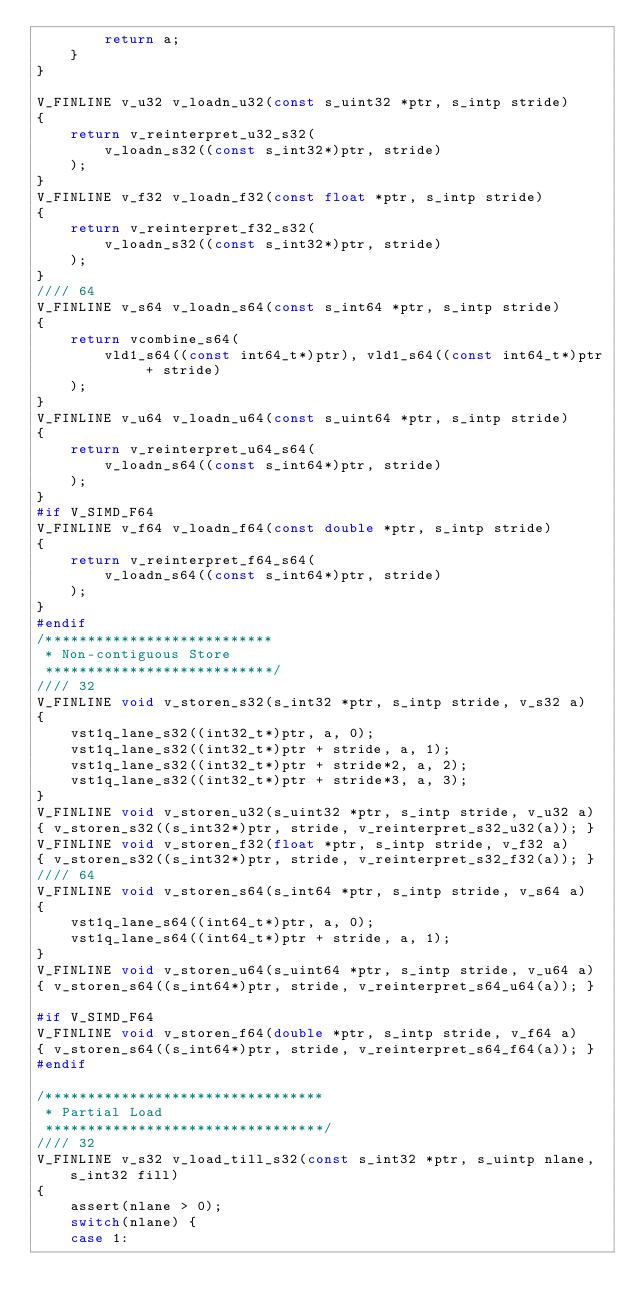Convert code to text. <code><loc_0><loc_0><loc_500><loc_500><_C_>        return a;
    }
}

V_FINLINE v_u32 v_loadn_u32(const s_uint32 *ptr, s_intp stride)
{
    return v_reinterpret_u32_s32(
        v_loadn_s32((const s_int32*)ptr, stride)
    );
}
V_FINLINE v_f32 v_loadn_f32(const float *ptr, s_intp stride)
{
    return v_reinterpret_f32_s32(
        v_loadn_s32((const s_int32*)ptr, stride)
    );
}
//// 64
V_FINLINE v_s64 v_loadn_s64(const s_int64 *ptr, s_intp stride)
{
    return vcombine_s64(
        vld1_s64((const int64_t*)ptr), vld1_s64((const int64_t*)ptr + stride)
    );
}
V_FINLINE v_u64 v_loadn_u64(const s_uint64 *ptr, s_intp stride)
{
    return v_reinterpret_u64_s64(
        v_loadn_s64((const s_int64*)ptr, stride)
    );
}
#if V_SIMD_F64
V_FINLINE v_f64 v_loadn_f64(const double *ptr, s_intp stride)
{
    return v_reinterpret_f64_s64(
        v_loadn_s64((const s_int64*)ptr, stride)
    );
}
#endif
/***************************
 * Non-contiguous Store
 ***************************/
//// 32
V_FINLINE void v_storen_s32(s_int32 *ptr, s_intp stride, v_s32 a)
{
    vst1q_lane_s32((int32_t*)ptr, a, 0);
    vst1q_lane_s32((int32_t*)ptr + stride, a, 1);
    vst1q_lane_s32((int32_t*)ptr + stride*2, a, 2);
    vst1q_lane_s32((int32_t*)ptr + stride*3, a, 3);
}
V_FINLINE void v_storen_u32(s_uint32 *ptr, s_intp stride, v_u32 a)
{ v_storen_s32((s_int32*)ptr, stride, v_reinterpret_s32_u32(a)); }
V_FINLINE void v_storen_f32(float *ptr, s_intp stride, v_f32 a)
{ v_storen_s32((s_int32*)ptr, stride, v_reinterpret_s32_f32(a)); }
//// 64
V_FINLINE void v_storen_s64(s_int64 *ptr, s_intp stride, v_s64 a)
{
    vst1q_lane_s64((int64_t*)ptr, a, 0);
    vst1q_lane_s64((int64_t*)ptr + stride, a, 1);
}
V_FINLINE void v_storen_u64(s_uint64 *ptr, s_intp stride, v_u64 a)
{ v_storen_s64((s_int64*)ptr, stride, v_reinterpret_s64_u64(a)); }

#if V_SIMD_F64
V_FINLINE void v_storen_f64(double *ptr, s_intp stride, v_f64 a)
{ v_storen_s64((s_int64*)ptr, stride, v_reinterpret_s64_f64(a)); }
#endif

/*********************************
 * Partial Load
 *********************************/
//// 32
V_FINLINE v_s32 v_load_till_s32(const s_int32 *ptr, s_uintp nlane, s_int32 fill)
{
    assert(nlane > 0);
    switch(nlane) {
    case 1:</code> 